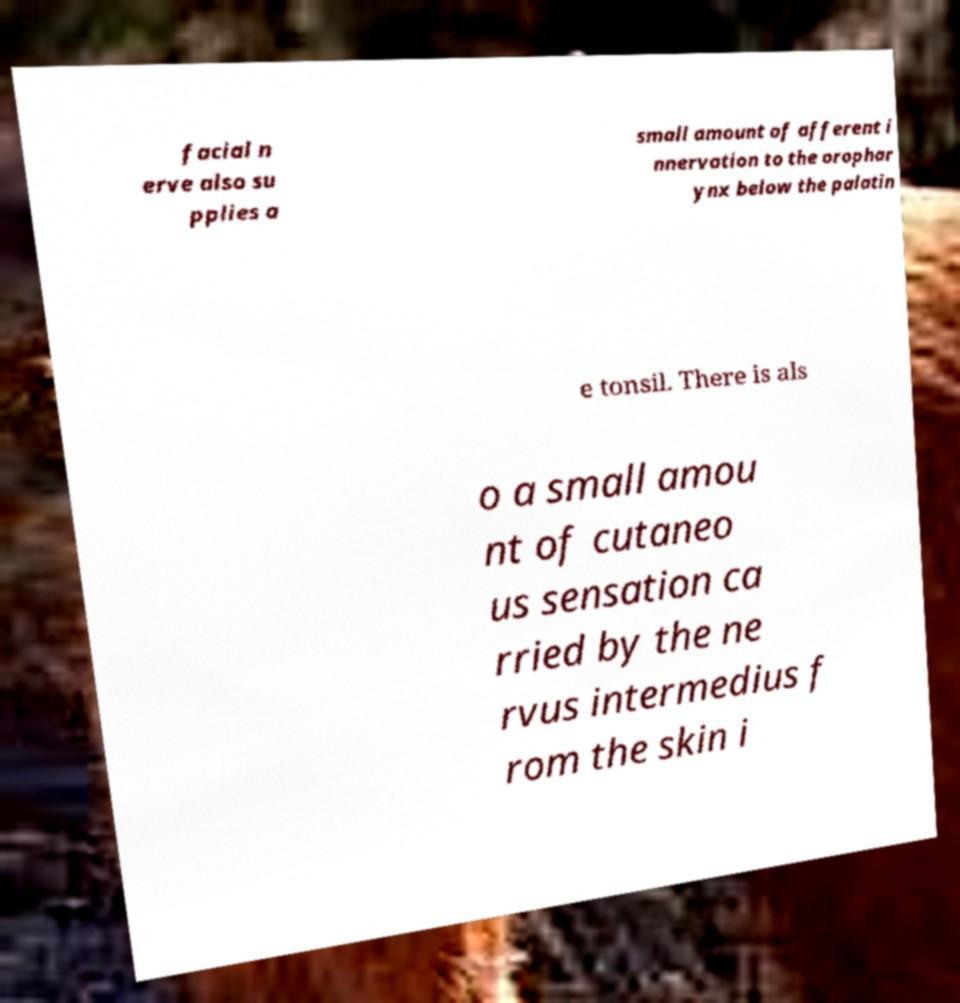There's text embedded in this image that I need extracted. Can you transcribe it verbatim? facial n erve also su pplies a small amount of afferent i nnervation to the orophar ynx below the palatin e tonsil. There is als o a small amou nt of cutaneo us sensation ca rried by the ne rvus intermedius f rom the skin i 